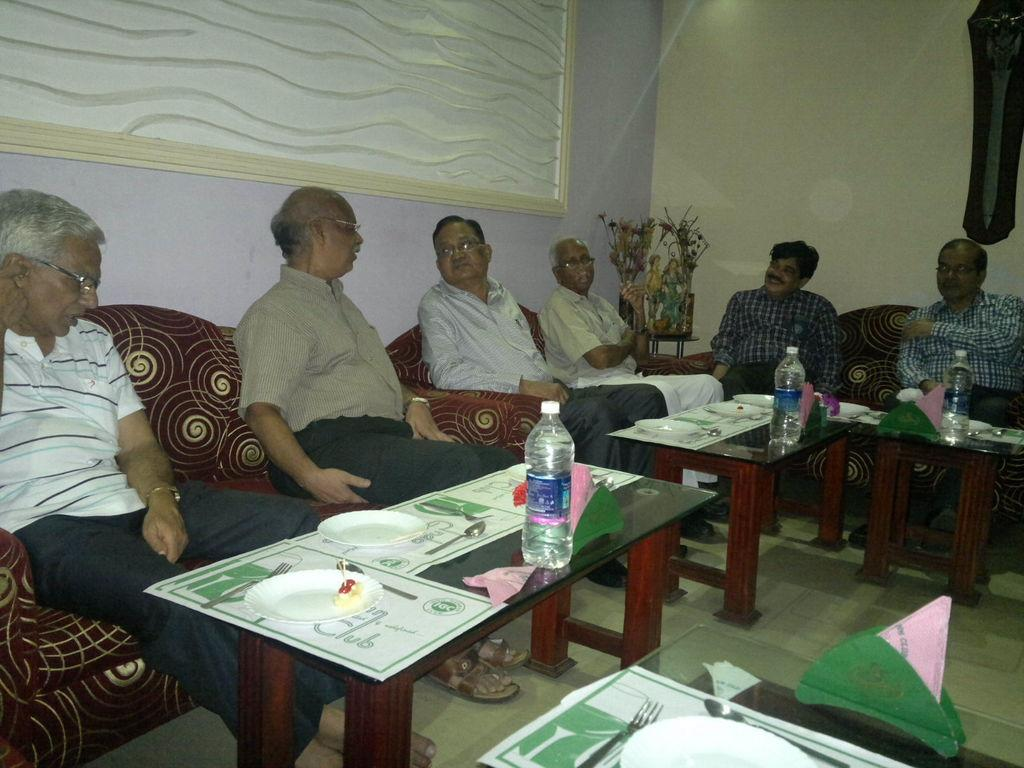What is the color of the wall in the image? The wall in the image is white. What are the people in the image doing? The people in the image are sitting on sofas. What objects are in front of the sofas? There are tables in front of the sofas. What can be found on one of the tables? There is a paper, plates, spoons, and a bottle on one of the tables. How many people are walking in the image? There are no people walking in the image; the people are sitting on sofas. 